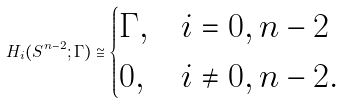<formula> <loc_0><loc_0><loc_500><loc_500>H _ { i } ( S ^ { n - 2 } ; \Gamma ) \cong \begin{cases} \Gamma , & i = 0 , n - 2 \\ 0 , & i \neq 0 , n - 2 . \end{cases}</formula> 